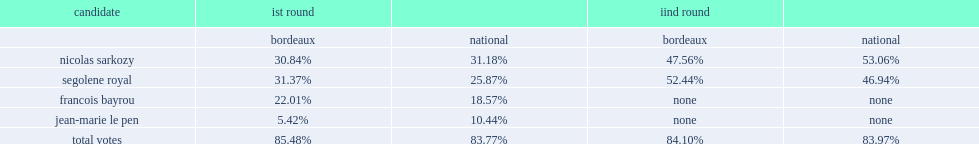Nationally, how many percent did nicolas sarkozy win? 31.18. 